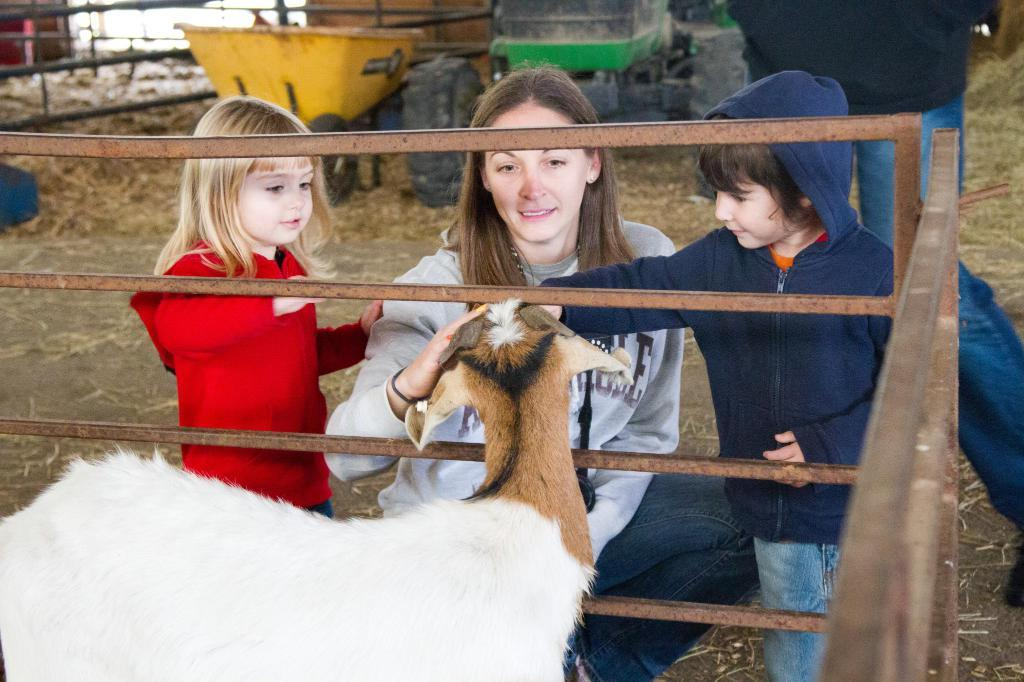What type of animal is in the image? There is an animal in the image, but its specific type cannot be determined from the provided facts. What is the material of the fencing in the image? There is metal fencing in the image. Who or what is in the foreground of the image? There are people in the foreground of the image. What is the cart used for in the image? The purpose of the cart in the image cannot be determined from the provided facts. What type of vehicle is in the image? There is a vehicle in the image, but its specific type cannot be determined from the provided facts. Can you describe the fencing in the background of the image? There is a metal fence in the background of the image. How many calculators are visible in the image? There is no calculator present in the image. What type of monkey can be seen interacting with the vehicle in the image? There is no monkey present in the image, and therefore no such interaction can be observed. 